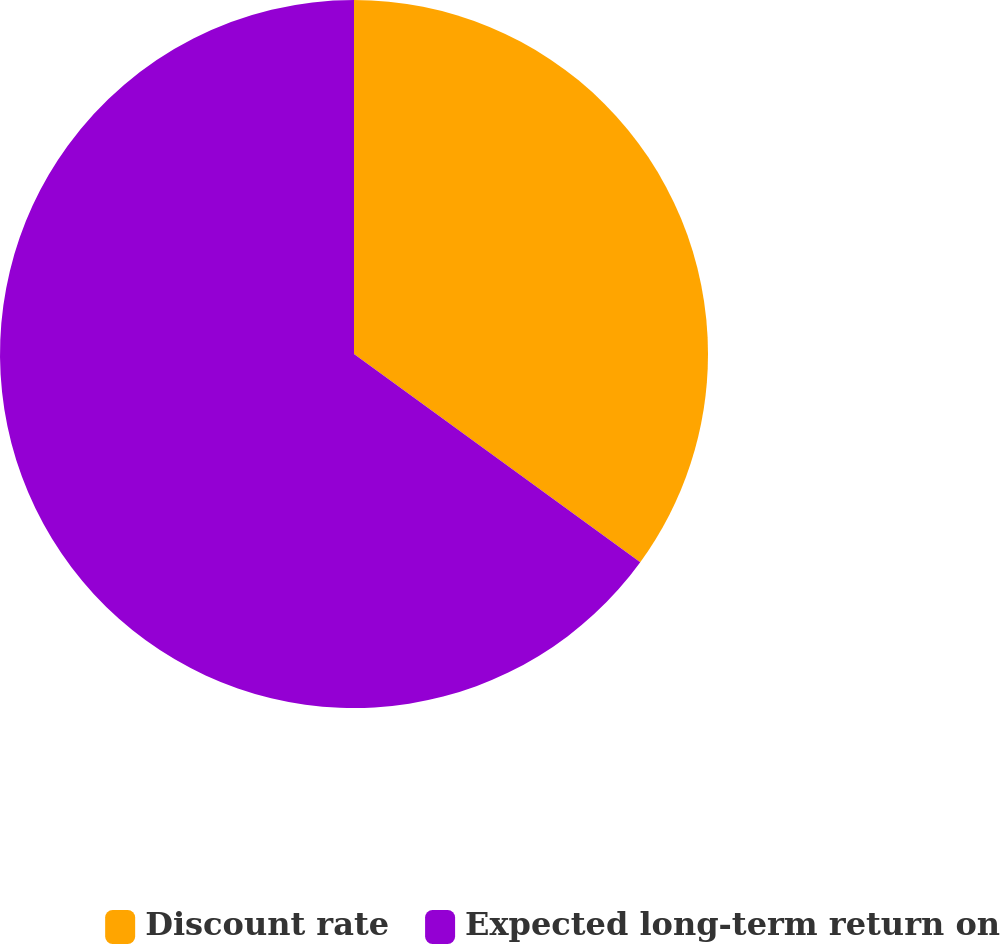Convert chart to OTSL. <chart><loc_0><loc_0><loc_500><loc_500><pie_chart><fcel>Discount rate<fcel>Expected long-term return on<nl><fcel>35.01%<fcel>64.99%<nl></chart> 